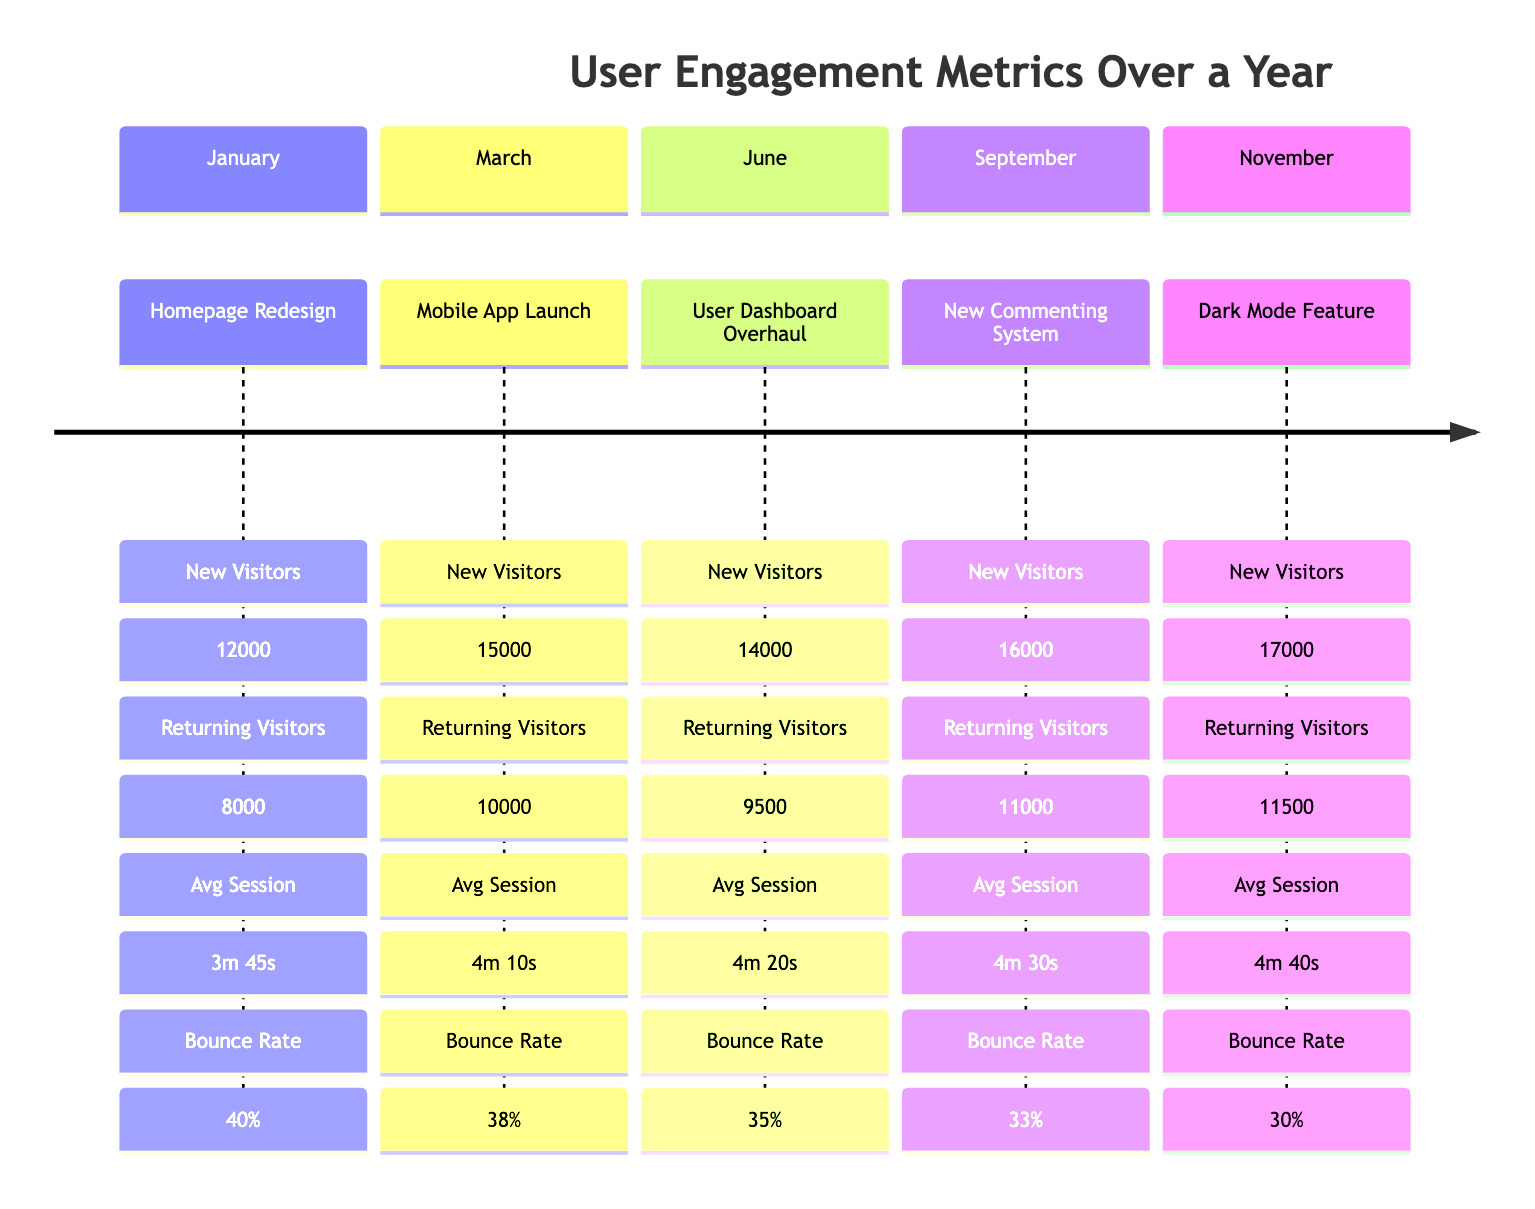What update was made in January? The annotation for January specifies "Homepage Redesign" as the design update made during that month.
Answer: Homepage Redesign How many new visitors were recorded in November? In the November annotation, the metrics detail that new visitors numbered 17000.
Answer: 17000 What was the returning visitor count for the month of June? The June section of the diagram indicates that returning visitors totaled 9500.
Answer: 9500 Which month had the lowest bounce rate? Reviewing each month's bounce rate, November has the lowest at 30% when compared to other months.
Answer: 30% How many new visitors did the Mobile App Launch attract? The metrics for the March update reveal that the Mobile App Launch attracted 15000 new visitors.
Answer: 15000 Which design update corresponds to the highest average session duration? The annotation for November indicates an average session duration of 4m 40s, which is the highest among all months.
Answer: 4m 40s How do the new visitors in September compare to those in March? September recorded 16000 new visitors, while March had 15000, showing an increase of 1000 visitors.
Answer: Increased by 1000 What was the bounce rate for the User Dashboard Overhaul in June? The metrics in June clearly state that the bounce rate was 35%.
Answer: 35% What is the trend of new visitors from January to November? Analyzing the data from January (12000) to November (17000), there is a consistent increase in new visitors each month.
Answer: Consistent increase 